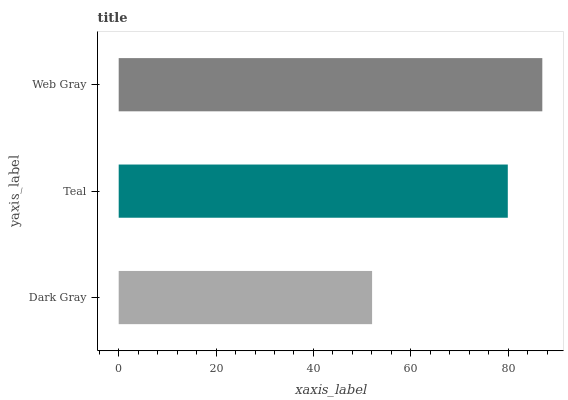Is Dark Gray the minimum?
Answer yes or no. Yes. Is Web Gray the maximum?
Answer yes or no. Yes. Is Teal the minimum?
Answer yes or no. No. Is Teal the maximum?
Answer yes or no. No. Is Teal greater than Dark Gray?
Answer yes or no. Yes. Is Dark Gray less than Teal?
Answer yes or no. Yes. Is Dark Gray greater than Teal?
Answer yes or no. No. Is Teal less than Dark Gray?
Answer yes or no. No. Is Teal the high median?
Answer yes or no. Yes. Is Teal the low median?
Answer yes or no. Yes. Is Dark Gray the high median?
Answer yes or no. No. Is Dark Gray the low median?
Answer yes or no. No. 